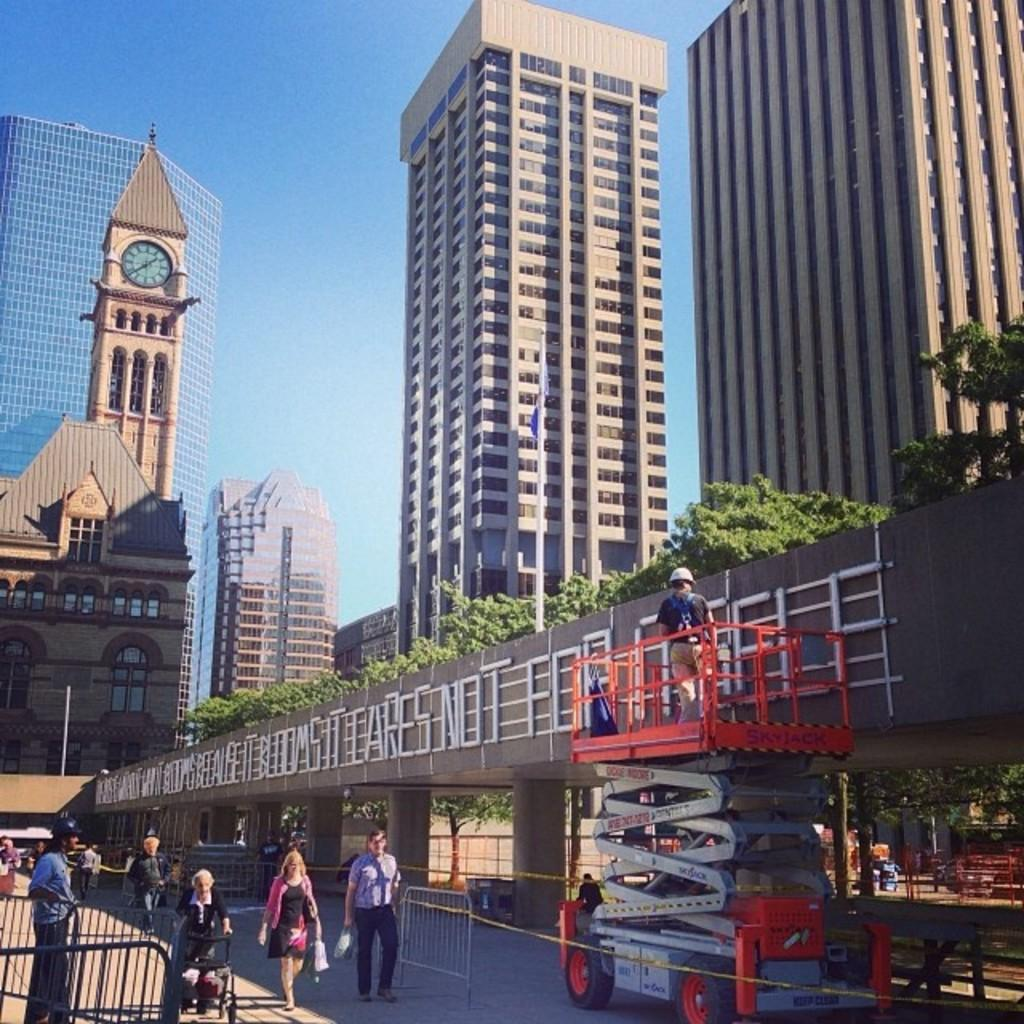What type of structures can be seen in the image? There are buildings in the image. What other natural elements are present in the image? There are trees in the image. What type of safety feature can be seen in the image? There are barrier grills in the image. What is the person on the road doing in the image? There is a person walking on the road in the image. What is the person on the motor vehicle doing in the image? There is a person standing on a motor vehicle in the image. What part of the natural environment is visible in the image? The sky is visible in the image. Can you tell me how many horses are tied to the trees in the image? There are no horses present in the image; it features buildings, trees, barrier grills, people walking and standing on a motor vehicle, and a visible sky. What type of locket is the person wearing around their neck in the image? There is no locket visible in the image; the focus is on the buildings, trees, barrier grills, people walking and standing on a motor vehicle, and the visible sky. 